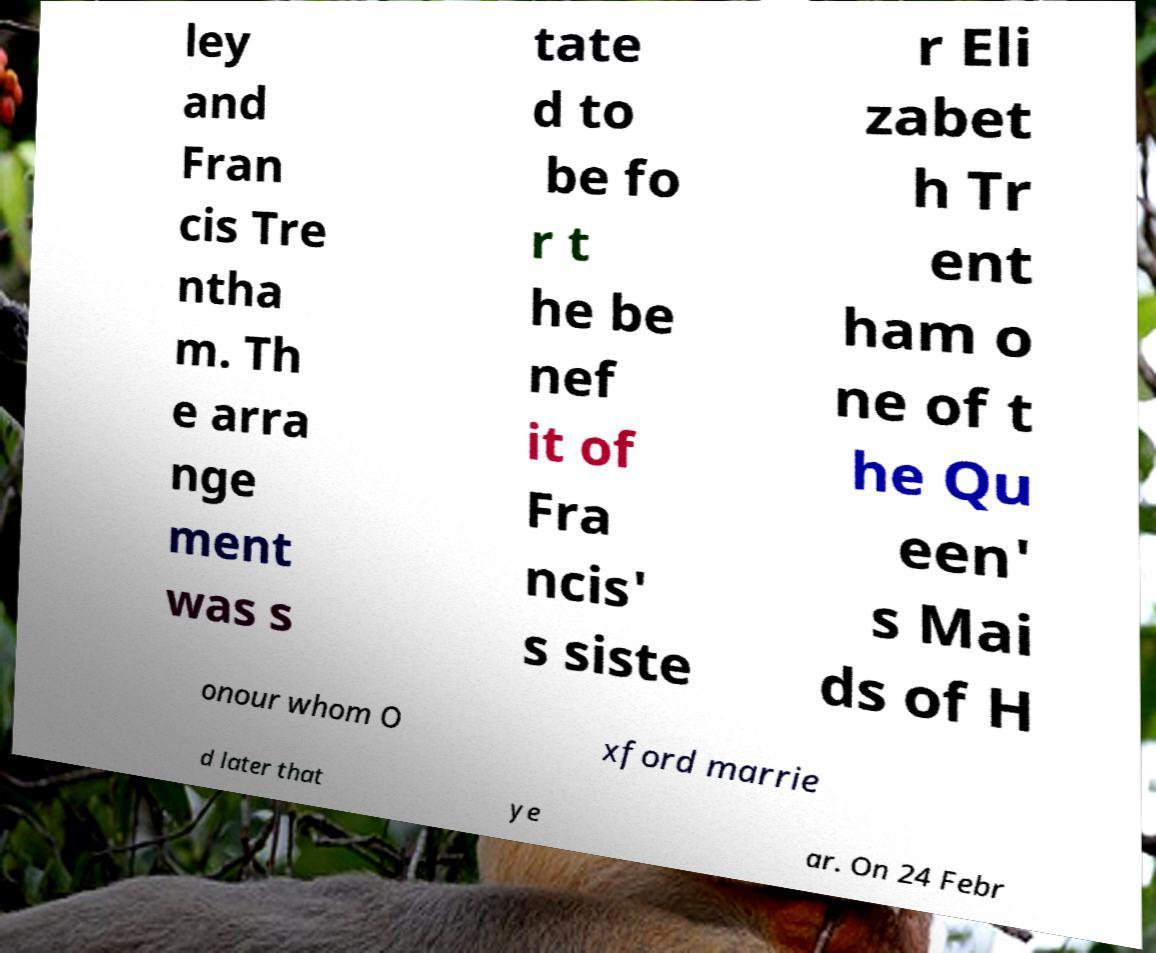Please read and relay the text visible in this image. What does it say? ley and Fran cis Tre ntha m. Th e arra nge ment was s tate d to be fo r t he be nef it of Fra ncis' s siste r Eli zabet h Tr ent ham o ne of t he Qu een' s Mai ds of H onour whom O xford marrie d later that ye ar. On 24 Febr 